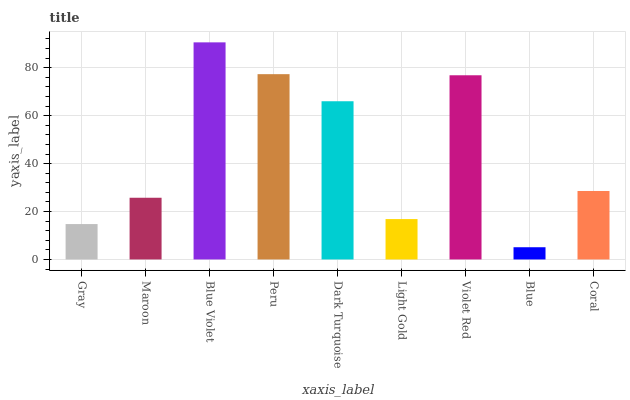Is Blue the minimum?
Answer yes or no. Yes. Is Blue Violet the maximum?
Answer yes or no. Yes. Is Maroon the minimum?
Answer yes or no. No. Is Maroon the maximum?
Answer yes or no. No. Is Maroon greater than Gray?
Answer yes or no. Yes. Is Gray less than Maroon?
Answer yes or no. Yes. Is Gray greater than Maroon?
Answer yes or no. No. Is Maroon less than Gray?
Answer yes or no. No. Is Coral the high median?
Answer yes or no. Yes. Is Coral the low median?
Answer yes or no. Yes. Is Blue the high median?
Answer yes or no. No. Is Violet Red the low median?
Answer yes or no. No. 